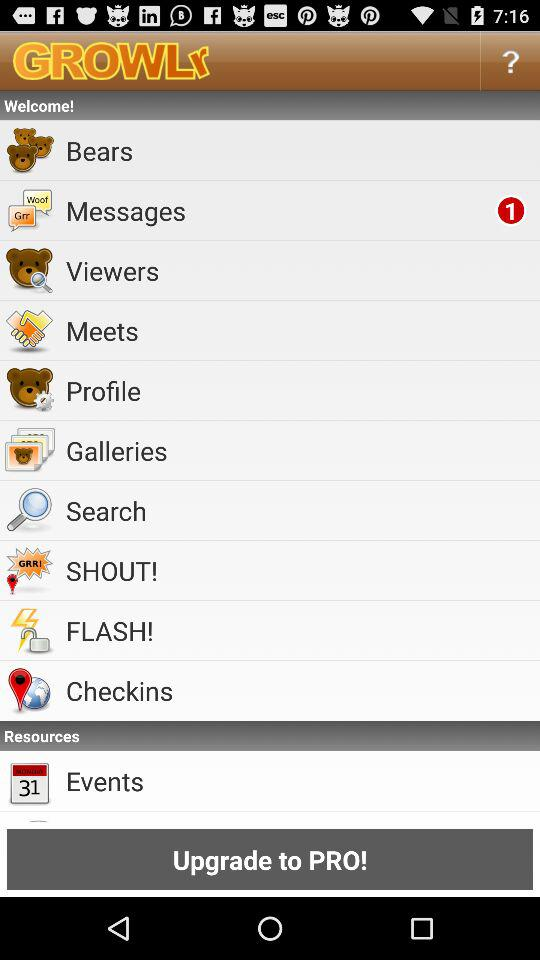How many unread messages are there? There is 1 unread message. 